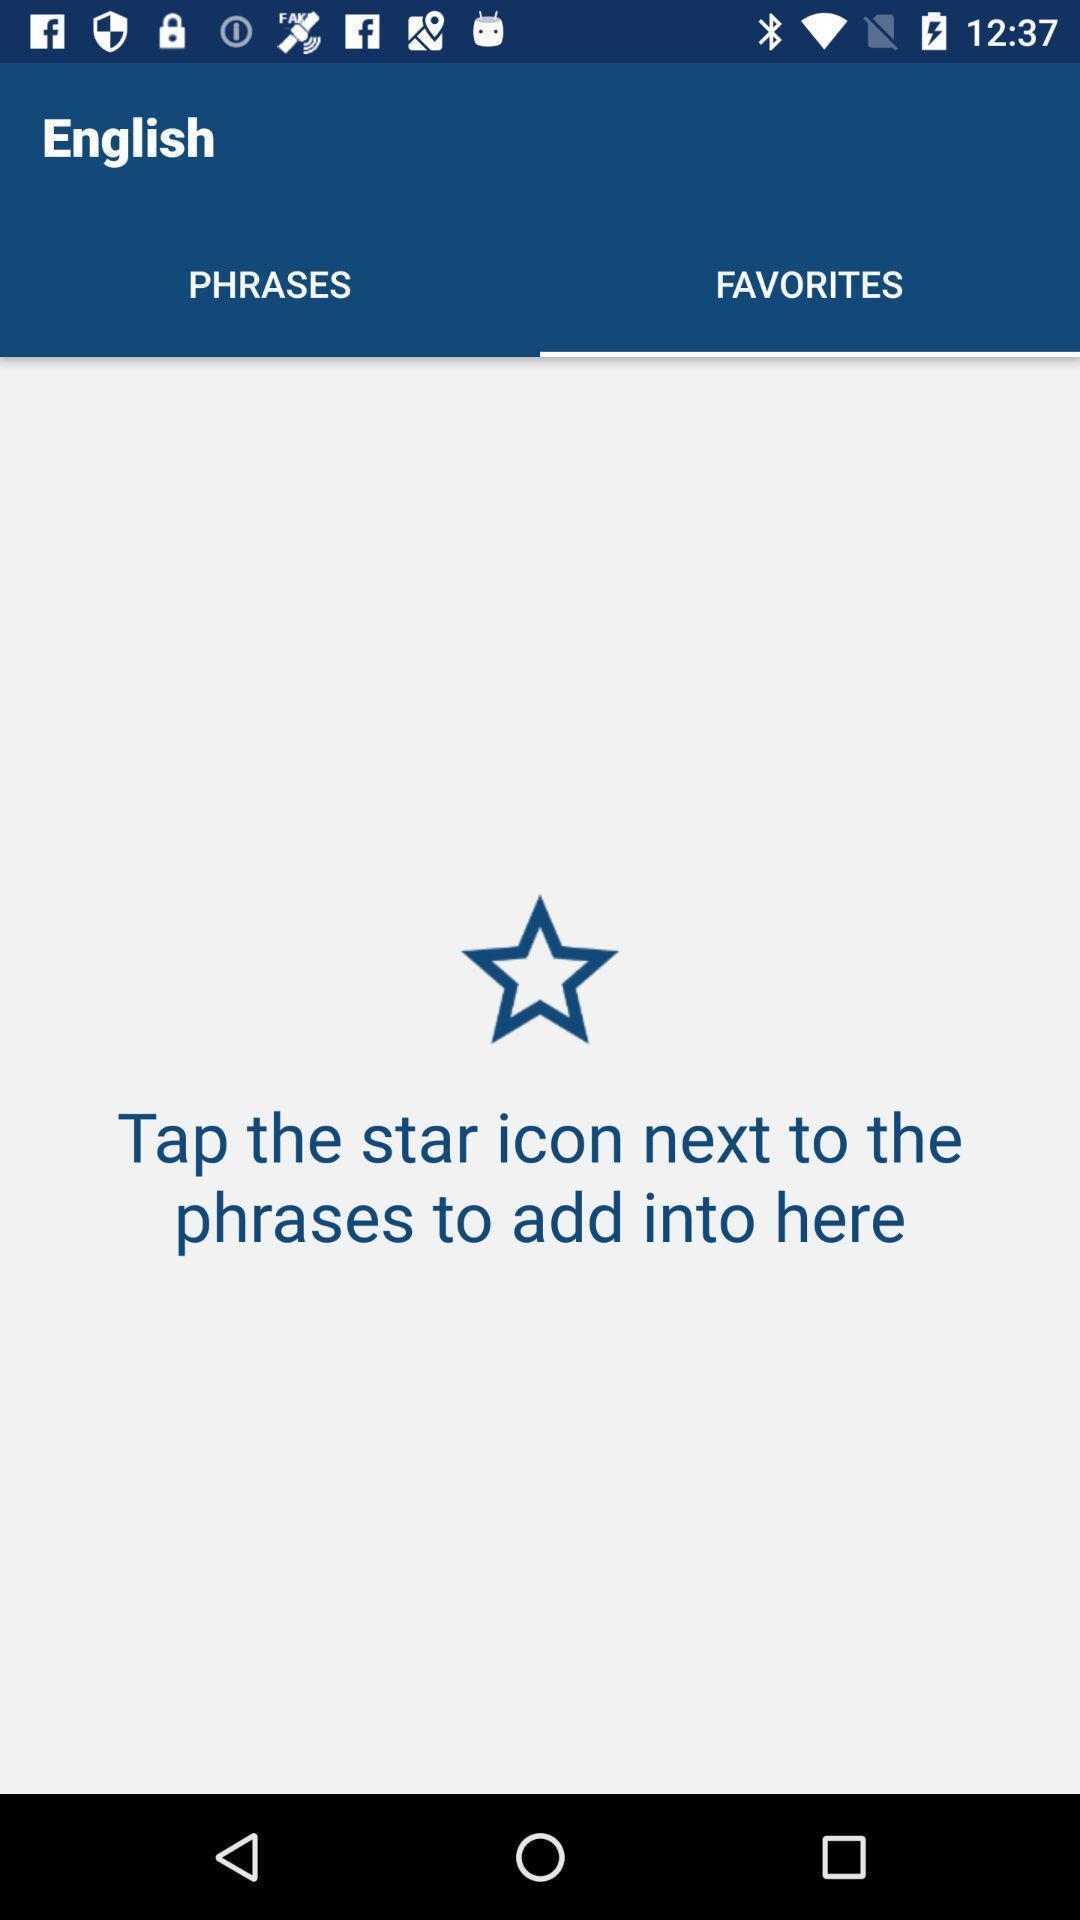What can you discern from this picture? Screen showing the blank page in favorites. 